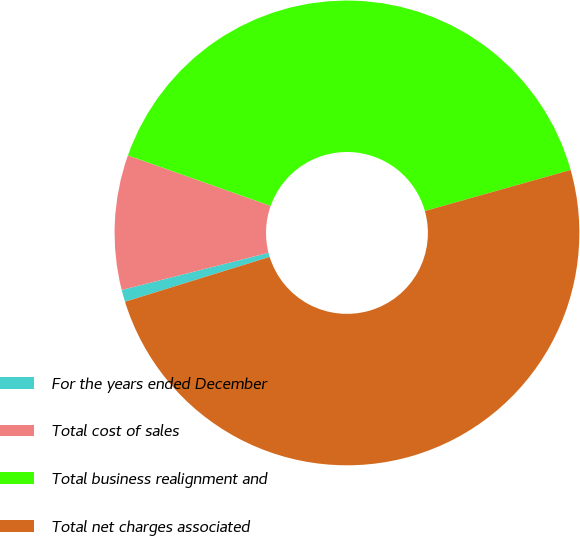<chart> <loc_0><loc_0><loc_500><loc_500><pie_chart><fcel>For the years ended December<fcel>Total cost of sales<fcel>Total business realignment and<fcel>Total net charges associated<nl><fcel>0.84%<fcel>9.36%<fcel>40.22%<fcel>49.58%<nl></chart> 